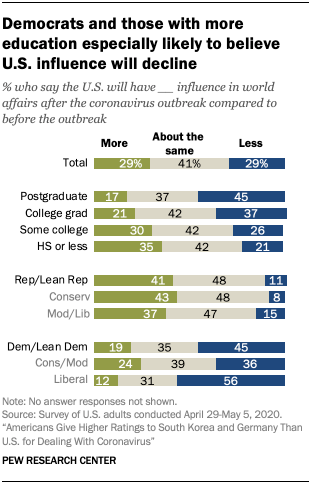Indicate a few pertinent items in this graphic. The median value of all the bars in College grad is 37. The total value is 29%. 